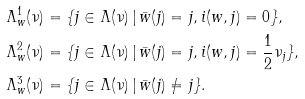Convert formula to latex. <formula><loc_0><loc_0><loc_500><loc_500>\Lambda _ { w } ^ { 1 } ( \nu ) & = \{ j \in \Lambda ( \nu ) \, | \, \bar { w } ( j ) = j , i ( w , j ) = 0 \} , \\ \Lambda _ { w } ^ { 2 } ( \nu ) & = \{ j \in \Lambda ( \nu ) \, | \, \bar { w } ( j ) = j , i ( w , j ) = \frac { 1 } { 2 } \nu _ { j } \} , \\ \Lambda _ { w } ^ { 3 } ( \nu ) & = \{ j \in \Lambda ( \nu ) \, | \, \bar { w } ( j ) \neq j \} .</formula> 